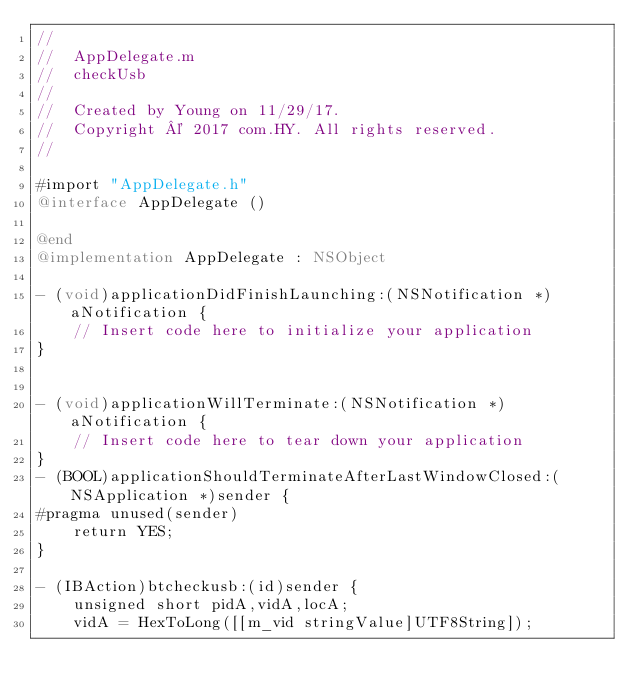<code> <loc_0><loc_0><loc_500><loc_500><_ObjectiveC_>//
//  AppDelegate.m
//  checkUsb
//
//  Created by Young on 11/29/17.
//  Copyright © 2017 com.HY. All rights reserved.
//

#import "AppDelegate.h"
@interface AppDelegate ()

@end
@implementation AppDelegate : NSObject 

- (void)applicationDidFinishLaunching:(NSNotification *)aNotification {
    // Insert code here to initialize your application
}


- (void)applicationWillTerminate:(NSNotification *)aNotification {
    // Insert code here to tear down your application
}
- (BOOL)applicationShouldTerminateAfterLastWindowClosed:(NSApplication *)sender {
#pragma unused(sender)
    return YES;
}

- (IBAction)btcheckusb:(id)sender {
    unsigned short pidA,vidA,locA;
    vidA = HexToLong([[m_vid stringValue]UTF8String]);</code> 